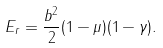<formula> <loc_0><loc_0><loc_500><loc_500>E _ { r } = \frac { b ^ { 2 } } { 2 } ( 1 - \mu ) ( 1 - \gamma ) .</formula> 